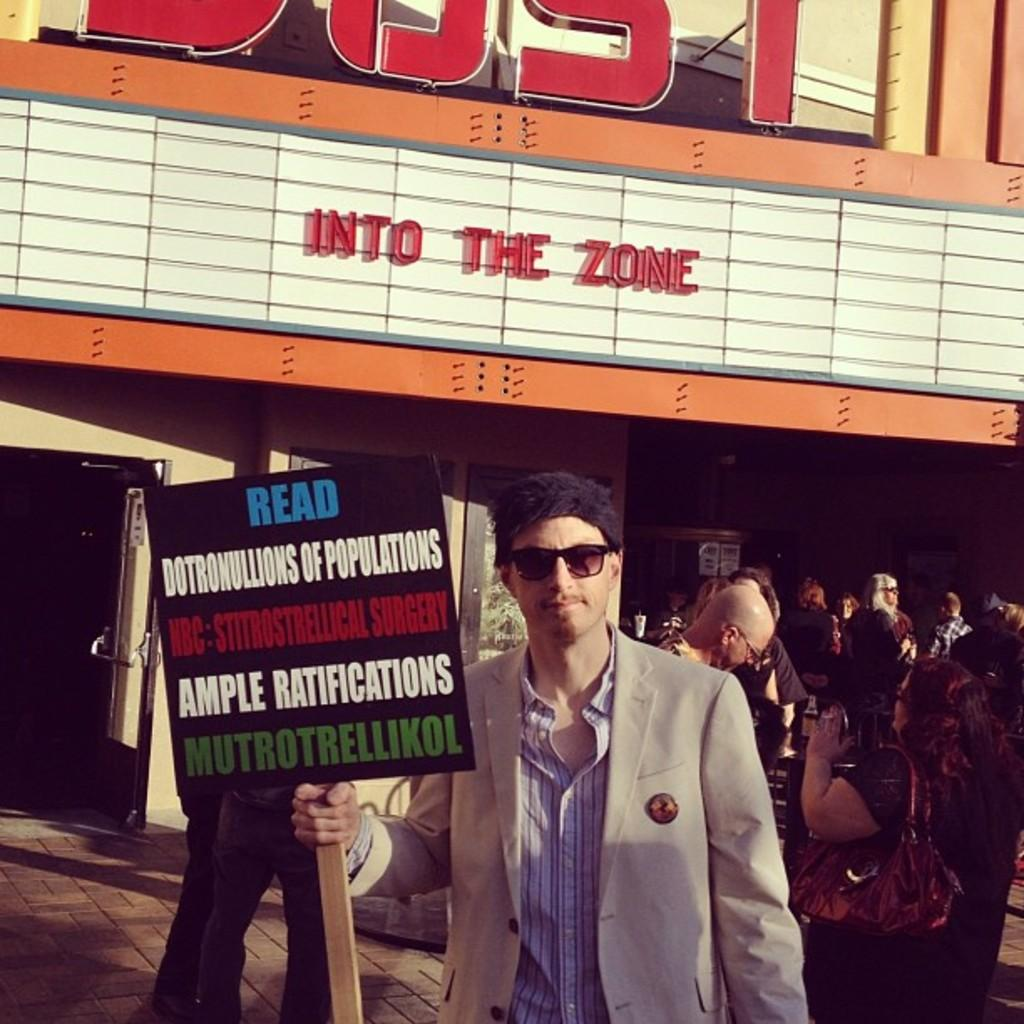What is the man in the image doing? The man is standing in the image and holding a board with a stick. Can you describe the man's appearance? The man is wearing glasses. Are there any other people visible in the image? Yes, there are people visible behind the man. What can be seen in the background of the image? There is a wall and a window in the background of the image. What type of line is the yak following in the image? There is no yak or line present in the image. Can you describe the man's facial expression in the image? The provided facts do not mention the man's facial expression, so we cannot describe it. 